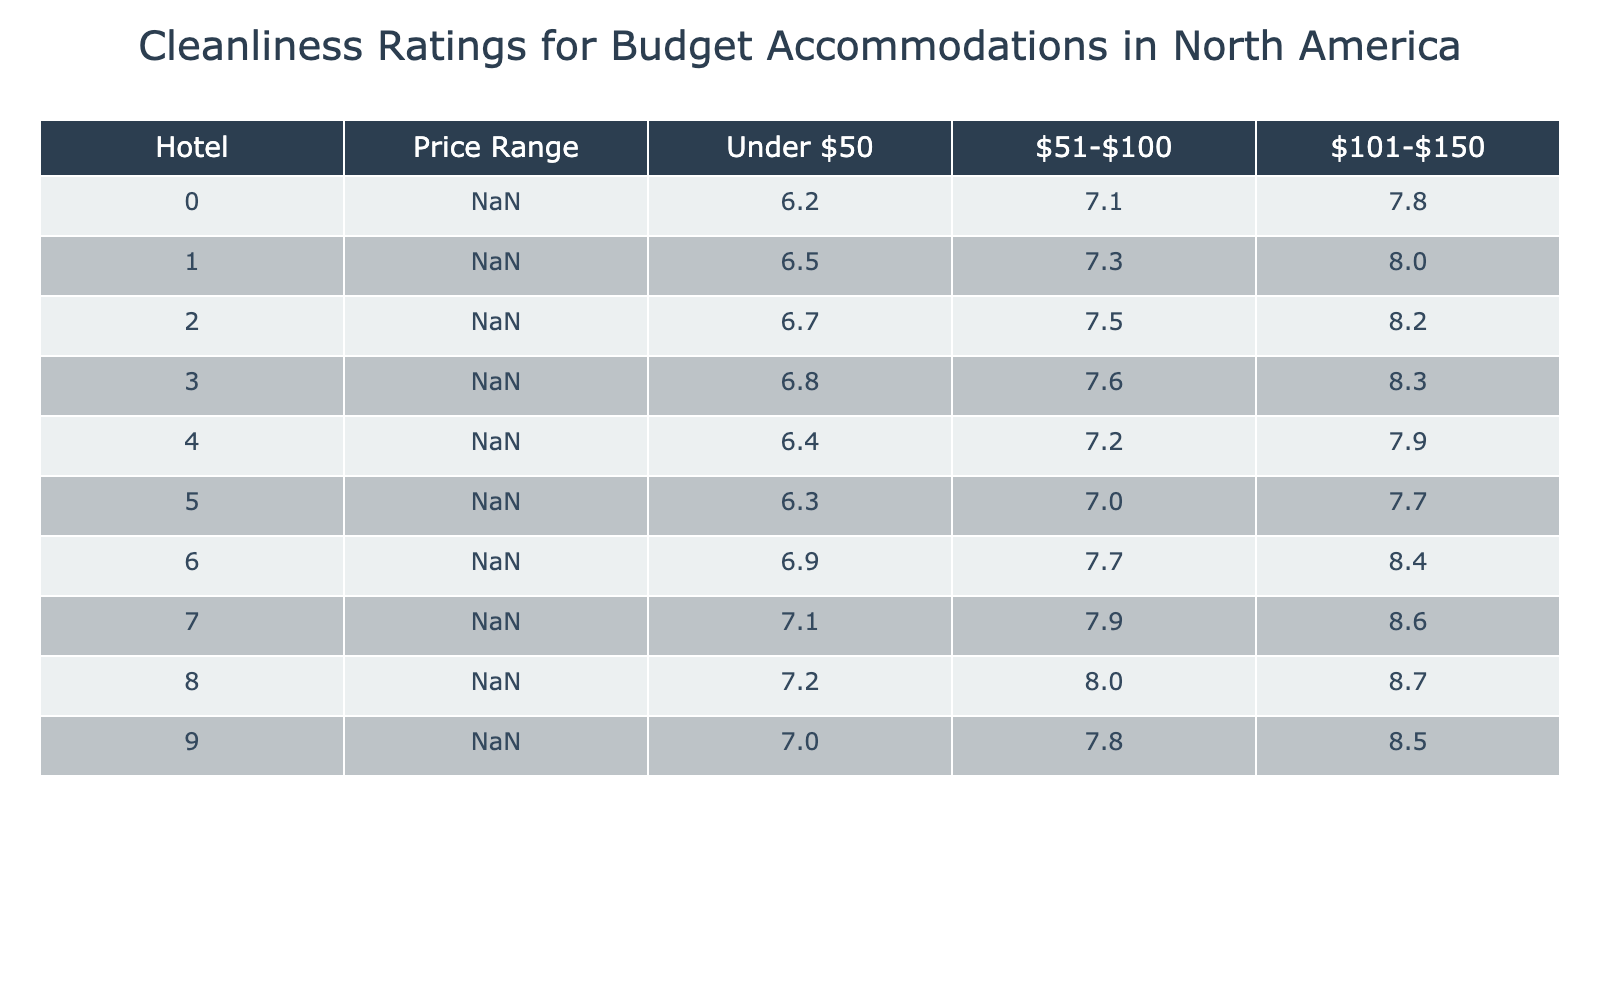What is the cleanliness rating for Best Western in the price range of $51-$100? The table shows the cleanliness rating for Best Western in the $51-$100 price range, which is 8.0.
Answer: 8.0 Which hotel has the highest cleanliness rating for accommodations under $50? By looking at the first column, Motel 6 has the highest cleanliness rating of 6.2 for accommodations under $50.
Answer: Motel 6 What is the cleanliness rating difference between Comfort Inn in the $101-$150 range and EconoLodge in the same range? Comfort Inn has a cleanliness rating of 8.6, while EconoLodge has a rating of 7.7. The difference is 8.6 - 7.7 = 0.9.
Answer: 0.9 Which hotel offers the lowest cleanliness rating in the $51-$100 price range? Super 8 offers the lowest cleanliness rating of 7.3 in the $51-$100 price range compared to the other hotels listed.
Answer: Super 8 What is the average cleanliness rating for the hotels listed in the price range of $101-$150? To find the average, sum the ratings: 7.8 + 8.0 + 8.2 + 8.3 + 7.9 + 7.7 + 8.4 + 8.6 + 8.7 + 8.5 = 88.7. There are 10 data points, so the average is 88.7 / 10 = 8.87.
Answer: 8.87 Is there a hotel that has a cleanliness rating of 8.4 in the $51-$100 range? The table indicates that Quality Inn has a cleanliness rating of 7.7 in the $51-$100 range; thus, no hotel has a rating of 8.4 in this range.
Answer: No Which hotel has a cleanliness rating that is consecutively improving across all three price ranges? By checking the rows, Comfort Inn shows a consecutive increase: 7.1 (under $50), 7.9 ($51-$100), and 8.6 ($101-$150), confirming an improvement in ratings.
Answer: Comfort Inn What is the sum of cleanliness ratings of Red Roof Inn in both price ranges of Under $50 and $51-$100? Red Roof Inn has cleanliness ratings of 6.8 (under $50) and 7.6 ($51-$100). Adding these ratings gives 6.8 + 7.6 = 14.4.
Answer: 14.4 Which hotel has the same cleanliness rating for Under $50 and $51-$100? Looking at the table, there is no hotel where the cleanliness rating remains the same for both price ranges.
Answer: No hotel What is the lowest cleanliness rating recorded for any hotel in the price range of under $50? The lowest cleanliness rating in the table for under $50 is 6.2, which belongs to Motel 6.
Answer: 6.2 